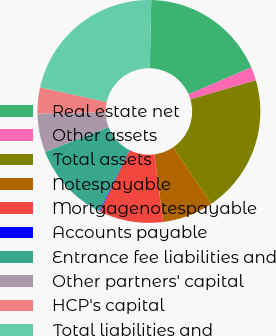Convert chart. <chart><loc_0><loc_0><loc_500><loc_500><pie_chart><fcel>Real estate net<fcel>Other assets<fcel>Total assets<fcel>Notespayable<fcel>Mortgagenotespayable<fcel>Accounts payable<fcel>Entrance fee liabilities and<fcel>Other partners' capital<fcel>HCP's capital<fcel>Total liabilities and<nl><fcel>18.21%<fcel>1.95%<fcel>20.04%<fcel>7.44%<fcel>9.27%<fcel>0.12%<fcel>11.73%<fcel>5.61%<fcel>3.78%<fcel>21.87%<nl></chart> 